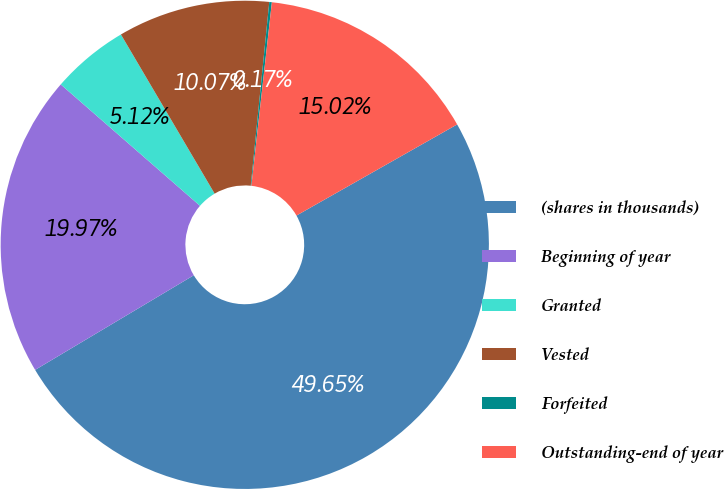Convert chart to OTSL. <chart><loc_0><loc_0><loc_500><loc_500><pie_chart><fcel>(shares in thousands)<fcel>Beginning of year<fcel>Granted<fcel>Vested<fcel>Forfeited<fcel>Outstanding-end of year<nl><fcel>49.65%<fcel>19.97%<fcel>5.12%<fcel>10.07%<fcel>0.17%<fcel>15.02%<nl></chart> 